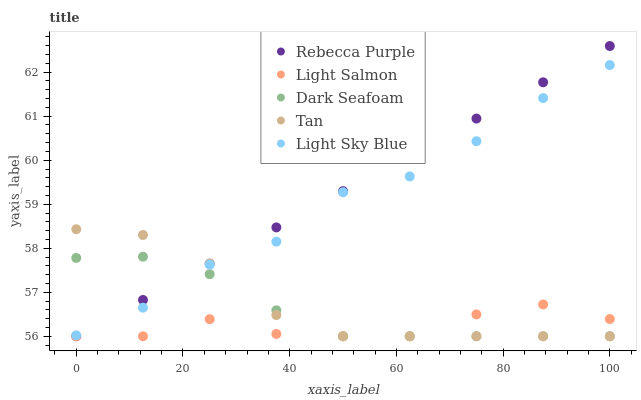Does Light Salmon have the minimum area under the curve?
Answer yes or no. Yes. Does Rebecca Purple have the maximum area under the curve?
Answer yes or no. Yes. Does Light Sky Blue have the minimum area under the curve?
Answer yes or no. No. Does Light Sky Blue have the maximum area under the curve?
Answer yes or no. No. Is Rebecca Purple the smoothest?
Answer yes or no. Yes. Is Light Sky Blue the roughest?
Answer yes or no. Yes. Is Tan the smoothest?
Answer yes or no. No. Is Tan the roughest?
Answer yes or no. No. Does Light Salmon have the lowest value?
Answer yes or no. Yes. Does Light Sky Blue have the lowest value?
Answer yes or no. No. Does Rebecca Purple have the highest value?
Answer yes or no. Yes. Does Light Sky Blue have the highest value?
Answer yes or no. No. Is Light Salmon less than Light Sky Blue?
Answer yes or no. Yes. Is Light Sky Blue greater than Light Salmon?
Answer yes or no. Yes. Does Rebecca Purple intersect Dark Seafoam?
Answer yes or no. Yes. Is Rebecca Purple less than Dark Seafoam?
Answer yes or no. No. Is Rebecca Purple greater than Dark Seafoam?
Answer yes or no. No. Does Light Salmon intersect Light Sky Blue?
Answer yes or no. No. 